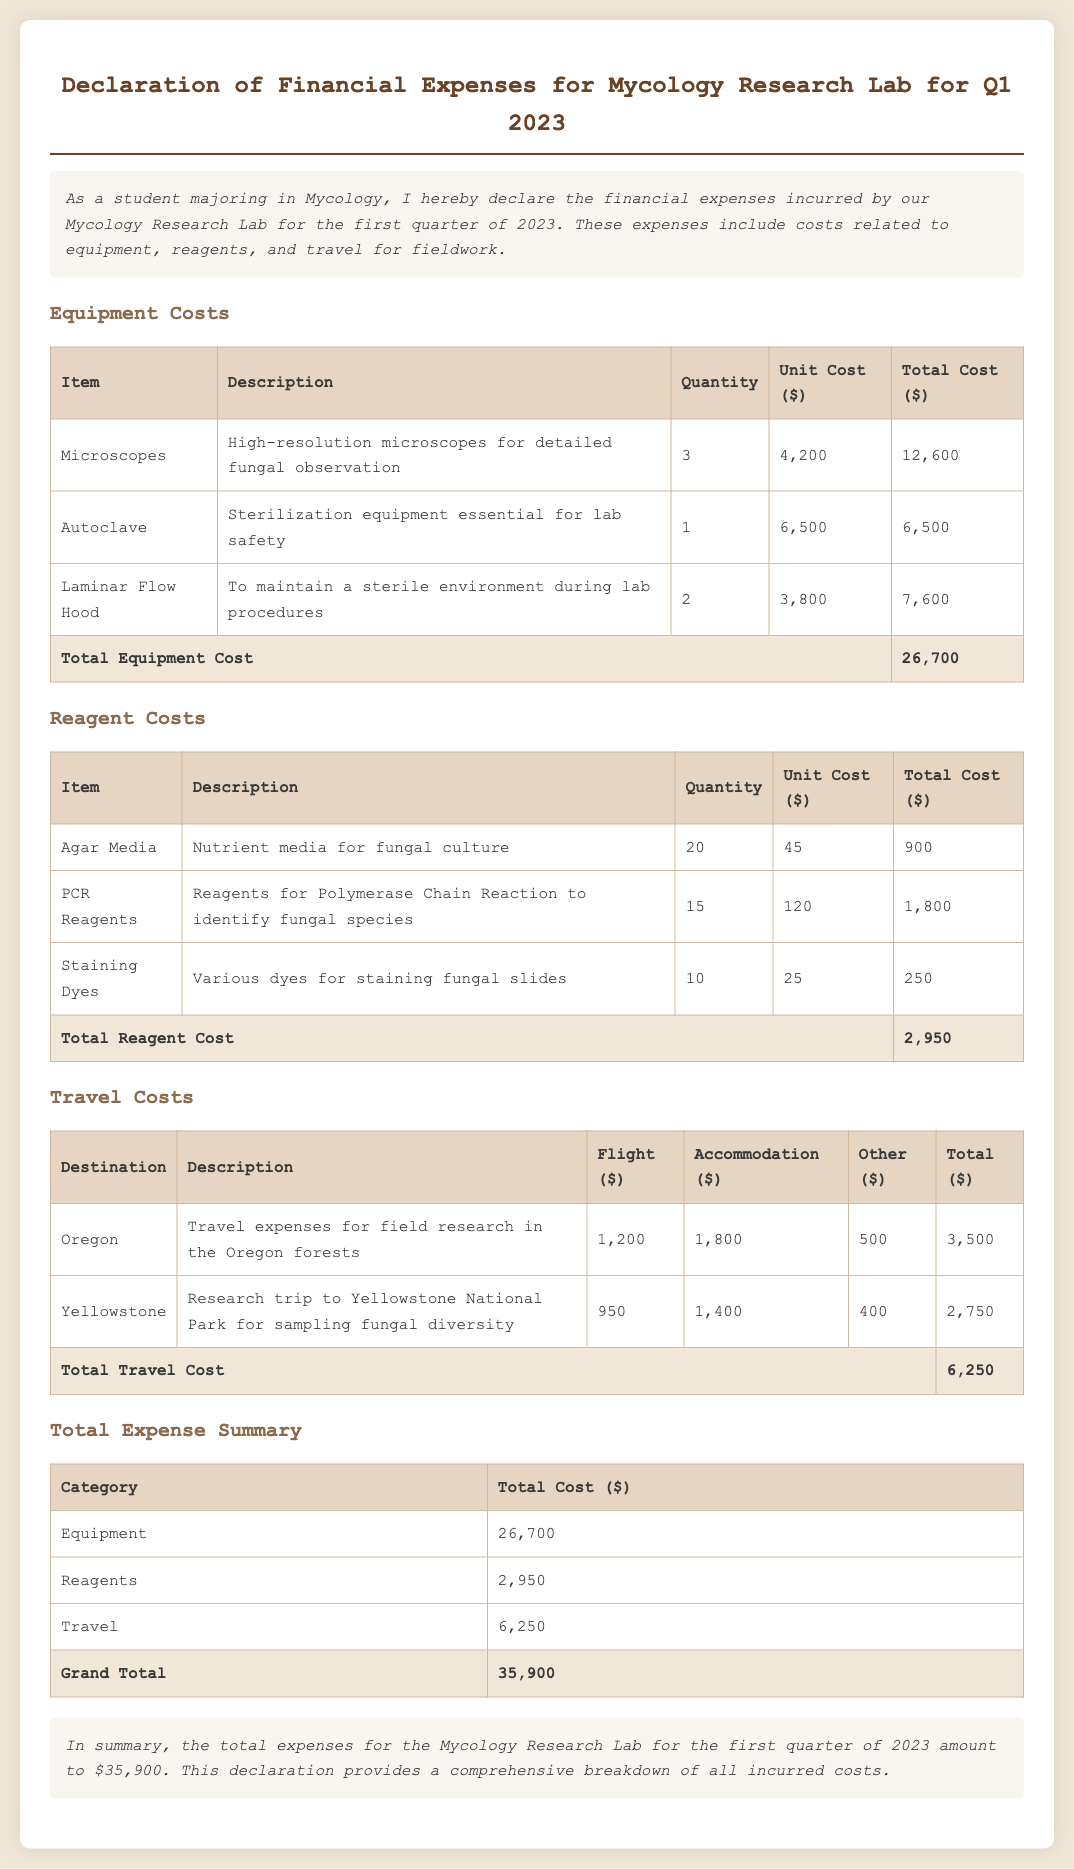What is the total equipment cost? The total cost of all equipment is stated in the document, which adds up to 12,600 + 6,500 + 7,600.
Answer: 26,700 How many microscopes were purchased? The document lists the quantity of microscopes under equipment costs, which is 3.
Answer: 3 What is the total reagent cost? The total cost associated with all reagents is summarized in the document, totaling 900 + 1,800 + 250.
Answer: 2,950 What is the destination of the travel expense for field research? The document mentions Oregon as the destination for field research expenses.
Answer: Oregon What is the grand total for the expenses listed? The document provides a summary of all costs, with the grand total calculated as 26,700 + 2,950 + 6,250.
Answer: 35,900 What type of equipment is mentioned for maintaining a sterile environment? The document specifies Laminar Flow Hood as the equipment for this purpose.
Answer: Laminar Flow Hood How many PCR reagents were acquired? The number of PCR reagents obtained as per the document is noted as 15.
Answer: 15 What are the costs associated with travel to Yellowstone? The document provides a breakdown of travel costs for the Yellowstone trip, totaling 2,750.
Answer: 2,750 What does the declaration summarize at the end? The declaration summarizes the total financial expenses incurred by the Mycology Research Lab for the first quarter of 2023.
Answer: Total expenses 